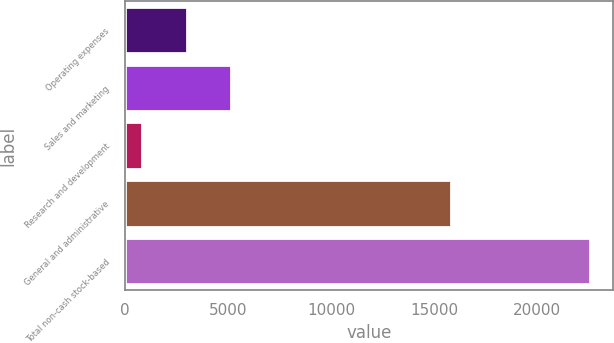<chart> <loc_0><loc_0><loc_500><loc_500><bar_chart><fcel>Operating expenses<fcel>Sales and marketing<fcel>Research and development<fcel>General and administrative<fcel>Total non-cash stock-based<nl><fcel>3007<fcel>5178<fcel>836<fcel>15837<fcel>22546<nl></chart> 